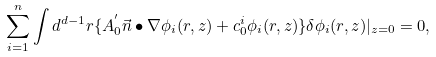<formula> <loc_0><loc_0><loc_500><loc_500>\sum _ { i = 1 } ^ { n } \int d ^ { d - 1 } r \{ A ^ { ^ { \prime } } _ { 0 } { \vec { n } } \bullet \nabla \phi _ { i } ( { r } , z ) + c ^ { i } _ { 0 } \phi _ { i } ( { r } , z ) \} \delta \phi _ { i } ( { r } , z ) | _ { z = 0 } = 0 ,</formula> 